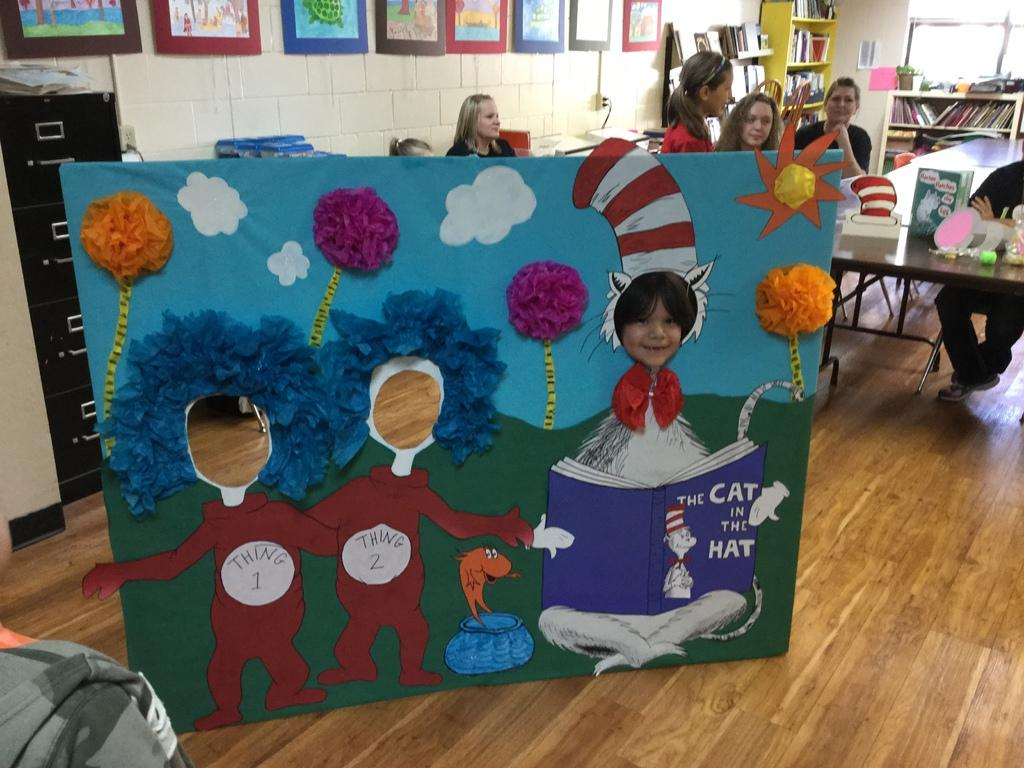<image>
Offer a succinct explanation of the picture presented. A child has his face in "The cat in the hat" face box. 